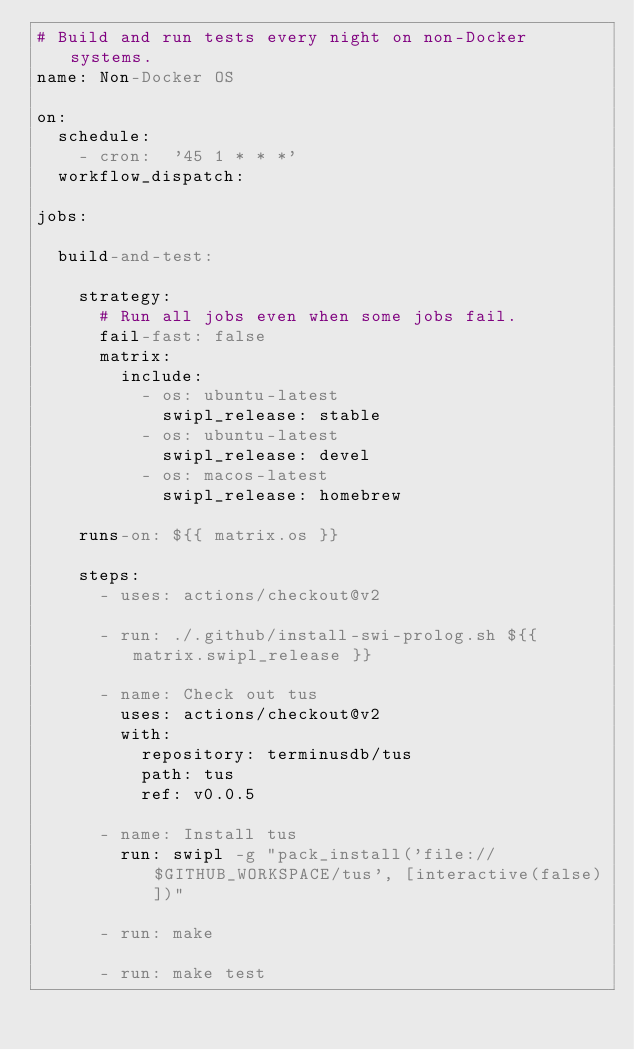Convert code to text. <code><loc_0><loc_0><loc_500><loc_500><_YAML_># Build and run tests every night on non-Docker systems.
name: Non-Docker OS

on:
  schedule:
    - cron:  '45 1 * * *'
  workflow_dispatch:

jobs:

  build-and-test:

    strategy:
      # Run all jobs even when some jobs fail.
      fail-fast: false
      matrix:
        include:
          - os: ubuntu-latest
            swipl_release: stable
          - os: ubuntu-latest
            swipl_release: devel
          - os: macos-latest
            swipl_release: homebrew

    runs-on: ${{ matrix.os }}

    steps:
      - uses: actions/checkout@v2

      - run: ./.github/install-swi-prolog.sh ${{ matrix.swipl_release }}

      - name: Check out tus
        uses: actions/checkout@v2
        with:
          repository: terminusdb/tus
          path: tus
          ref: v0.0.5

      - name: Install tus
        run: swipl -g "pack_install('file://$GITHUB_WORKSPACE/tus', [interactive(false)])"

      - run: make

      - run: make test
</code> 